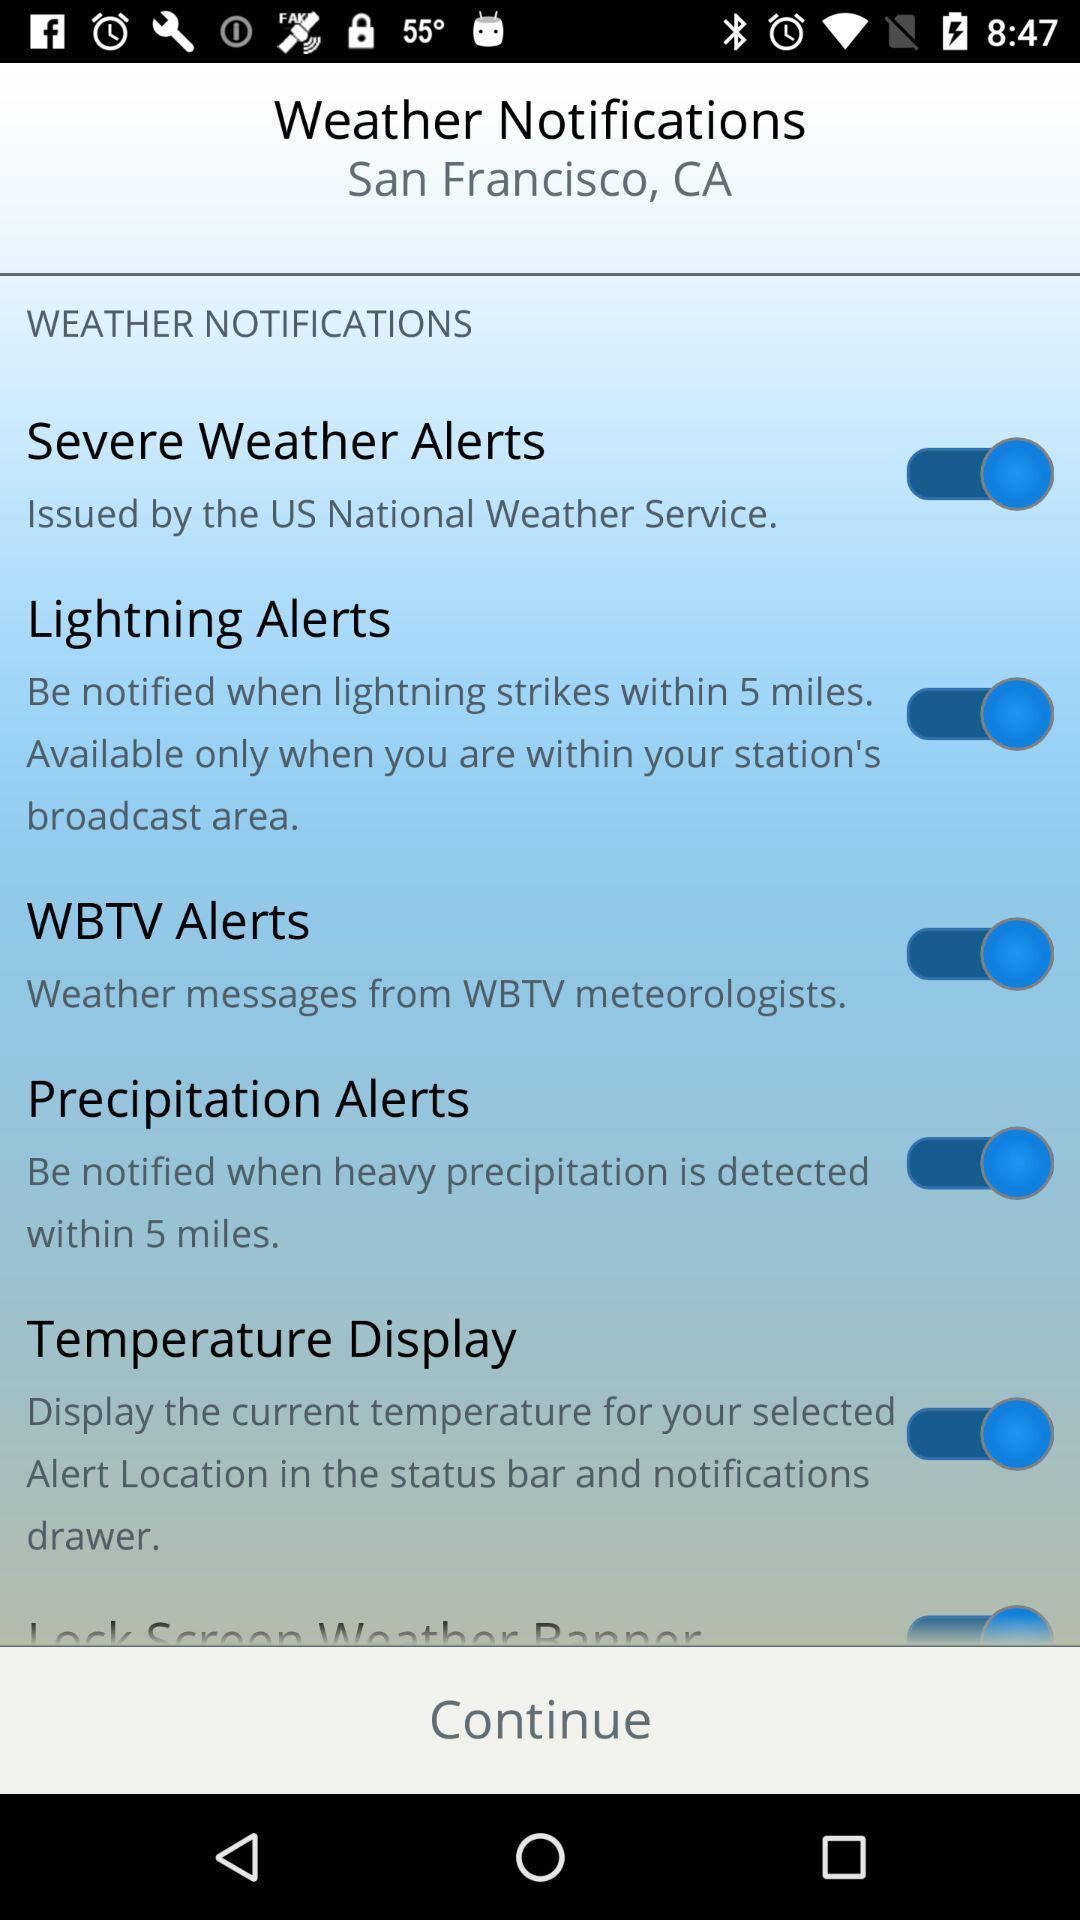What is the location? The location is San Francisco, CA. 